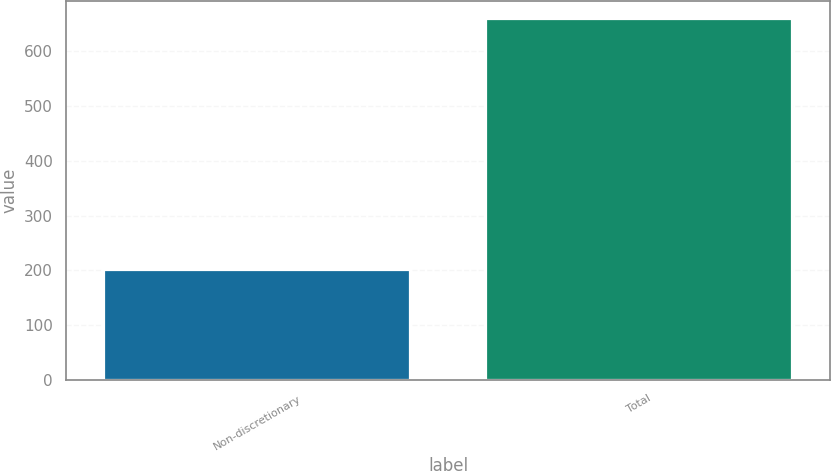<chart> <loc_0><loc_0><loc_500><loc_500><bar_chart><fcel>Non-discretionary<fcel>Total<nl><fcel>200<fcel>659<nl></chart> 